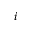Convert formula to latex. <formula><loc_0><loc_0><loc_500><loc_500>i</formula> 